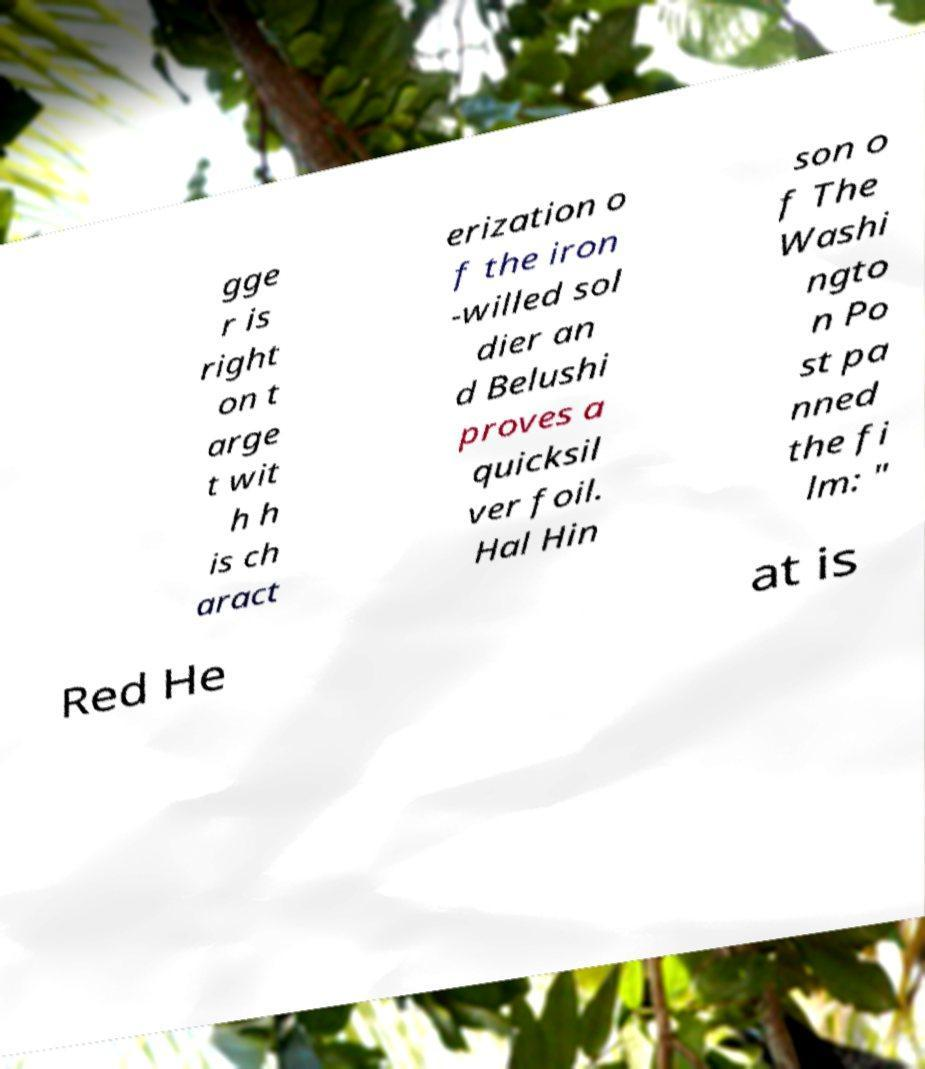For documentation purposes, I need the text within this image transcribed. Could you provide that? gge r is right on t arge t wit h h is ch aract erization o f the iron -willed sol dier an d Belushi proves a quicksil ver foil. Hal Hin son o f The Washi ngto n Po st pa nned the fi lm: " Red He at is 